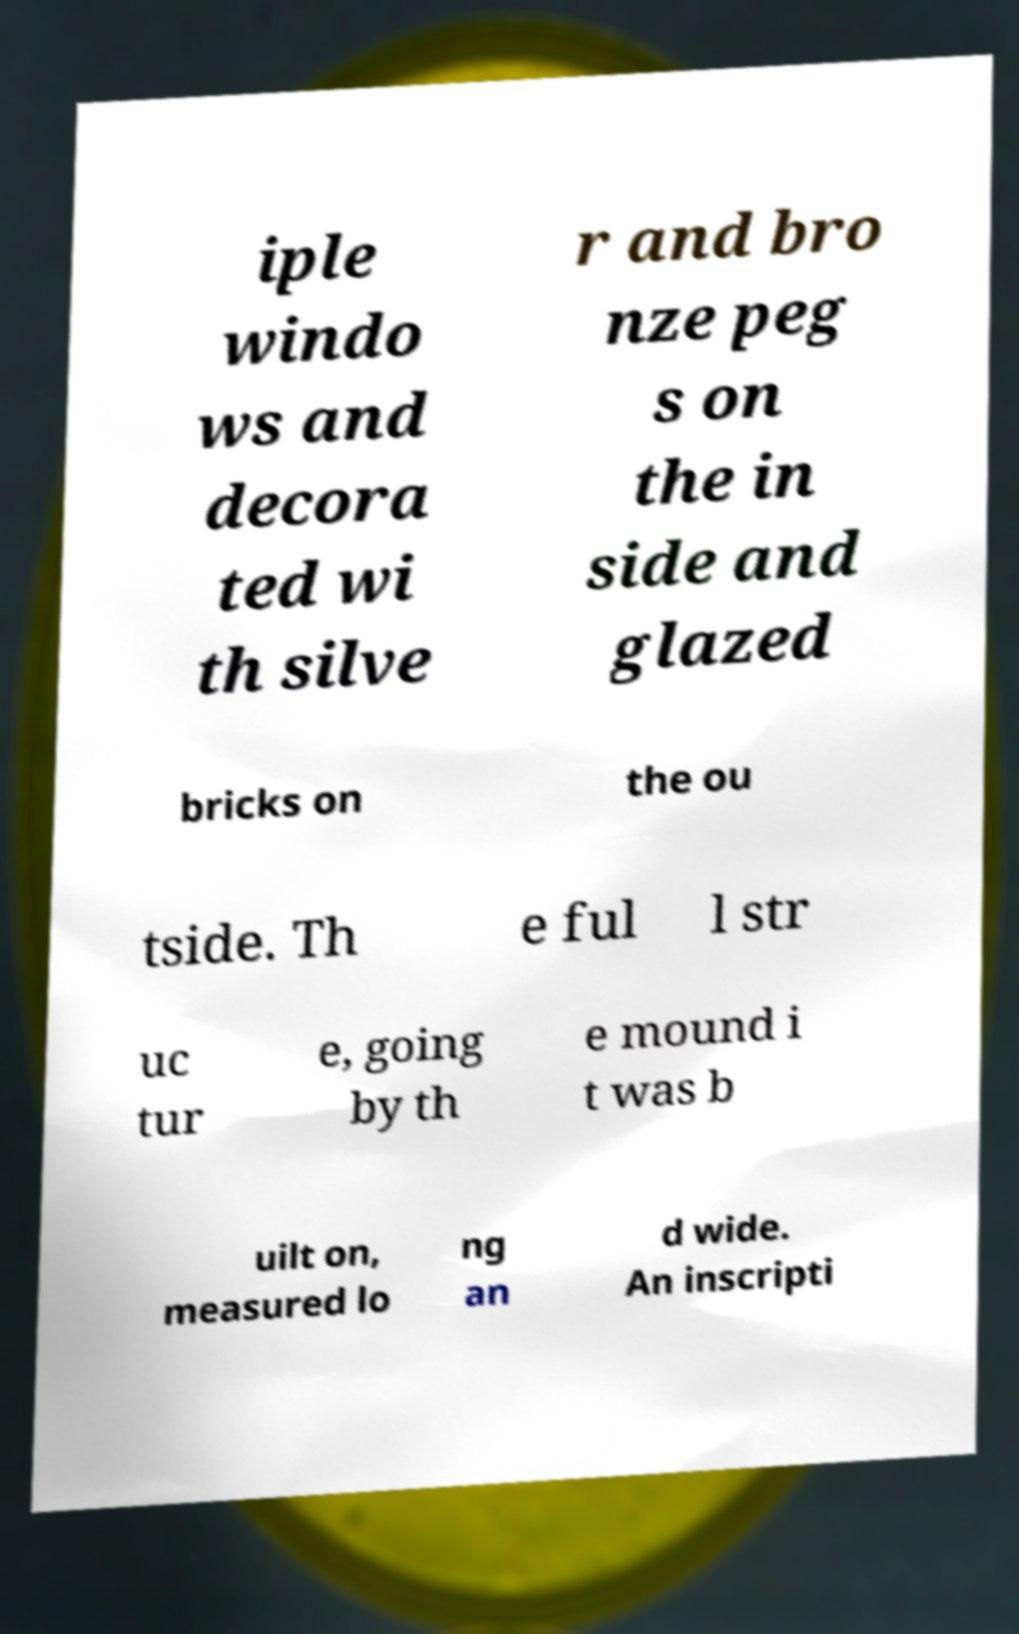I need the written content from this picture converted into text. Can you do that? iple windo ws and decora ted wi th silve r and bro nze peg s on the in side and glazed bricks on the ou tside. Th e ful l str uc tur e, going by th e mound i t was b uilt on, measured lo ng an d wide. An inscripti 